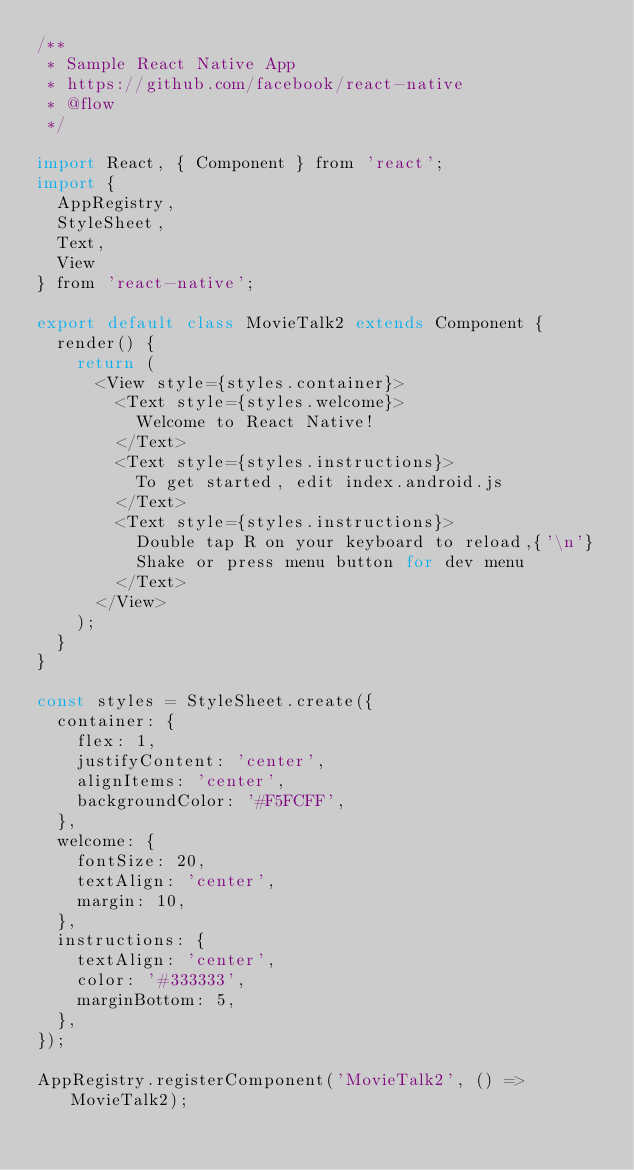<code> <loc_0><loc_0><loc_500><loc_500><_JavaScript_>/**
 * Sample React Native App
 * https://github.com/facebook/react-native
 * @flow
 */

import React, { Component } from 'react';
import {
  AppRegistry,
  StyleSheet,
  Text,
  View
} from 'react-native';

export default class MovieTalk2 extends Component {
  render() {
    return (
      <View style={styles.container}>
        <Text style={styles.welcome}>
          Welcome to React Native!
        </Text>
        <Text style={styles.instructions}>
          To get started, edit index.android.js
        </Text>
        <Text style={styles.instructions}>
          Double tap R on your keyboard to reload,{'\n'}
          Shake or press menu button for dev menu
        </Text>
      </View>
    );
  }
}

const styles = StyleSheet.create({
  container: {
    flex: 1,
    justifyContent: 'center',
    alignItems: 'center',
    backgroundColor: '#F5FCFF',
  },
  welcome: {
    fontSize: 20,
    textAlign: 'center',
    margin: 10,
  },
  instructions: {
    textAlign: 'center',
    color: '#333333',
    marginBottom: 5,
  },
});

AppRegistry.registerComponent('MovieTalk2', () => MovieTalk2);
</code> 